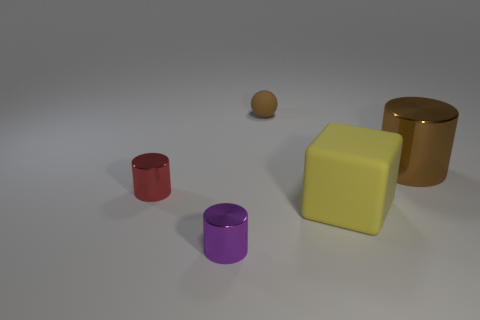How many things are brown rubber spheres or big objects?
Your answer should be compact. 3. What number of red cylinders have the same material as the small ball?
Your answer should be very brief. 0. Is the number of small blue shiny cylinders less than the number of tiny purple cylinders?
Your response must be concise. Yes. Are the large object in front of the large brown cylinder and the brown cylinder made of the same material?
Your answer should be very brief. No. What number of spheres are either metal things or large metallic objects?
Ensure brevity in your answer.  0. There is a shiny thing that is behind the big yellow object and left of the big brown metal object; what is its shape?
Give a very brief answer. Cylinder. What is the color of the small metal thing that is to the right of the cylinder that is left of the object that is in front of the yellow object?
Offer a very short reply. Purple. Is the number of big yellow matte objects that are behind the rubber ball less than the number of small yellow balls?
Offer a terse response. No. There is a tiny metallic object that is on the right side of the small red metallic cylinder; does it have the same shape as the metallic thing that is on the right side of the small purple object?
Offer a terse response. Yes. How many things are either matte things behind the large yellow matte thing or brown shiny objects?
Make the answer very short. 2. 